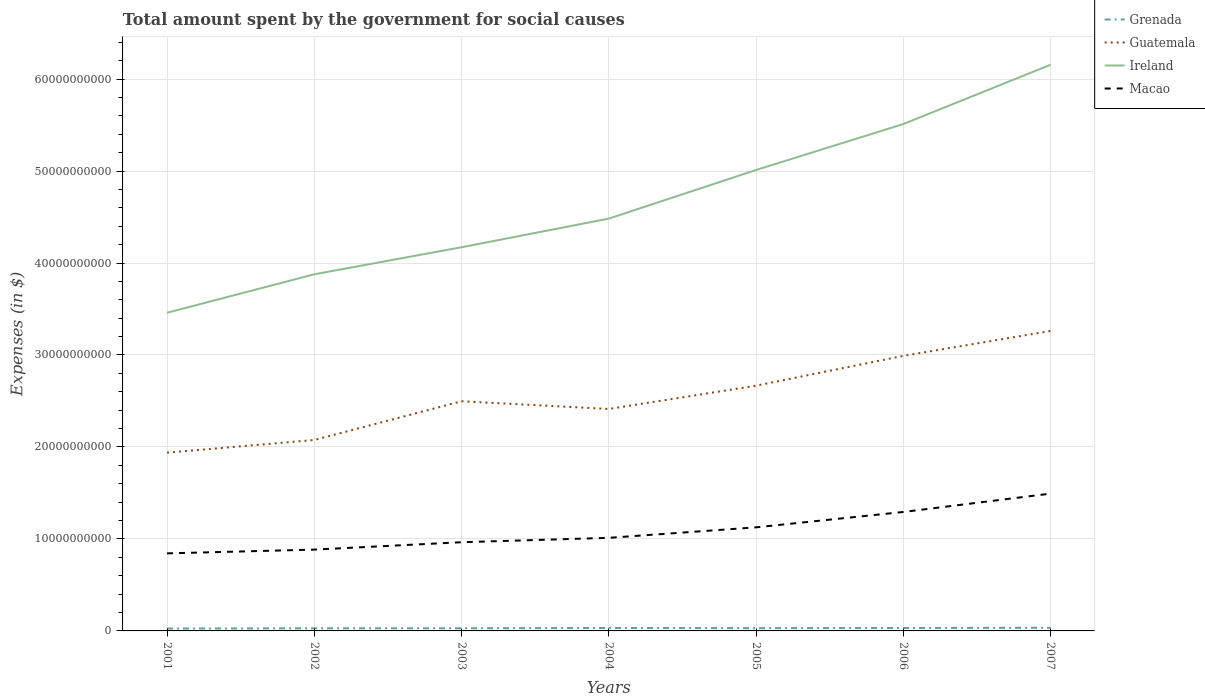How many different coloured lines are there?
Keep it short and to the point. 4. Does the line corresponding to Ireland intersect with the line corresponding to Grenada?
Your answer should be very brief. No. Across all years, what is the maximum amount spent for social causes by the government in Ireland?
Offer a terse response. 3.46e+1. What is the total amount spent for social causes by the government in Guatemala in the graph?
Offer a terse response. -9.15e+09. What is the difference between the highest and the second highest amount spent for social causes by the government in Grenada?
Keep it short and to the point. 8.76e+07. Does the graph contain any zero values?
Provide a short and direct response. No. Does the graph contain grids?
Keep it short and to the point. Yes. Where does the legend appear in the graph?
Provide a short and direct response. Top right. What is the title of the graph?
Your answer should be very brief. Total amount spent by the government for social causes. Does "East Asia (developing only)" appear as one of the legend labels in the graph?
Make the answer very short. No. What is the label or title of the X-axis?
Provide a succinct answer. Years. What is the label or title of the Y-axis?
Your response must be concise. Expenses (in $). What is the Expenses (in $) of Grenada in 2001?
Keep it short and to the point. 2.58e+08. What is the Expenses (in $) in Guatemala in 2001?
Provide a short and direct response. 1.94e+1. What is the Expenses (in $) in Ireland in 2001?
Provide a short and direct response. 3.46e+1. What is the Expenses (in $) of Macao in 2001?
Your answer should be compact. 8.43e+09. What is the Expenses (in $) in Grenada in 2002?
Ensure brevity in your answer.  2.83e+08. What is the Expenses (in $) in Guatemala in 2002?
Keep it short and to the point. 2.08e+1. What is the Expenses (in $) of Ireland in 2002?
Your response must be concise. 3.88e+1. What is the Expenses (in $) in Macao in 2002?
Offer a terse response. 8.84e+09. What is the Expenses (in $) in Grenada in 2003?
Your answer should be very brief. 2.86e+08. What is the Expenses (in $) of Guatemala in 2003?
Your response must be concise. 2.50e+1. What is the Expenses (in $) in Ireland in 2003?
Keep it short and to the point. 4.17e+1. What is the Expenses (in $) of Macao in 2003?
Your response must be concise. 9.64e+09. What is the Expenses (in $) in Grenada in 2004?
Provide a short and direct response. 3.21e+08. What is the Expenses (in $) in Guatemala in 2004?
Your answer should be very brief. 2.41e+1. What is the Expenses (in $) of Ireland in 2004?
Provide a short and direct response. 4.48e+1. What is the Expenses (in $) in Macao in 2004?
Offer a terse response. 1.01e+1. What is the Expenses (in $) in Grenada in 2005?
Offer a very short reply. 3.01e+08. What is the Expenses (in $) of Guatemala in 2005?
Your answer should be very brief. 2.67e+1. What is the Expenses (in $) in Ireland in 2005?
Provide a short and direct response. 5.01e+1. What is the Expenses (in $) of Macao in 2005?
Offer a terse response. 1.13e+1. What is the Expenses (in $) in Grenada in 2006?
Your answer should be very brief. 3.18e+08. What is the Expenses (in $) of Guatemala in 2006?
Offer a terse response. 2.99e+1. What is the Expenses (in $) in Ireland in 2006?
Ensure brevity in your answer.  5.51e+1. What is the Expenses (in $) in Macao in 2006?
Ensure brevity in your answer.  1.29e+1. What is the Expenses (in $) in Grenada in 2007?
Give a very brief answer. 3.46e+08. What is the Expenses (in $) in Guatemala in 2007?
Your answer should be compact. 3.26e+1. What is the Expenses (in $) in Ireland in 2007?
Offer a terse response. 6.16e+1. What is the Expenses (in $) of Macao in 2007?
Offer a terse response. 1.49e+1. Across all years, what is the maximum Expenses (in $) in Grenada?
Your answer should be very brief. 3.46e+08. Across all years, what is the maximum Expenses (in $) in Guatemala?
Provide a short and direct response. 3.26e+1. Across all years, what is the maximum Expenses (in $) of Ireland?
Your answer should be very brief. 6.16e+1. Across all years, what is the maximum Expenses (in $) of Macao?
Make the answer very short. 1.49e+1. Across all years, what is the minimum Expenses (in $) of Grenada?
Offer a very short reply. 2.58e+08. Across all years, what is the minimum Expenses (in $) of Guatemala?
Provide a short and direct response. 1.94e+1. Across all years, what is the minimum Expenses (in $) in Ireland?
Ensure brevity in your answer.  3.46e+1. Across all years, what is the minimum Expenses (in $) of Macao?
Your answer should be compact. 8.43e+09. What is the total Expenses (in $) in Grenada in the graph?
Ensure brevity in your answer.  2.11e+09. What is the total Expenses (in $) in Guatemala in the graph?
Your answer should be very brief. 1.78e+11. What is the total Expenses (in $) in Ireland in the graph?
Provide a short and direct response. 3.27e+11. What is the total Expenses (in $) of Macao in the graph?
Your answer should be very brief. 7.62e+1. What is the difference between the Expenses (in $) in Grenada in 2001 and that in 2002?
Keep it short and to the point. -2.49e+07. What is the difference between the Expenses (in $) in Guatemala in 2001 and that in 2002?
Offer a terse response. -1.38e+09. What is the difference between the Expenses (in $) of Ireland in 2001 and that in 2002?
Ensure brevity in your answer.  -4.18e+09. What is the difference between the Expenses (in $) in Macao in 2001 and that in 2002?
Provide a short and direct response. -4.10e+08. What is the difference between the Expenses (in $) of Grenada in 2001 and that in 2003?
Ensure brevity in your answer.  -2.73e+07. What is the difference between the Expenses (in $) in Guatemala in 2001 and that in 2003?
Provide a short and direct response. -5.59e+09. What is the difference between the Expenses (in $) in Ireland in 2001 and that in 2003?
Keep it short and to the point. -7.12e+09. What is the difference between the Expenses (in $) in Macao in 2001 and that in 2003?
Your answer should be compact. -1.21e+09. What is the difference between the Expenses (in $) in Grenada in 2001 and that in 2004?
Ensure brevity in your answer.  -6.24e+07. What is the difference between the Expenses (in $) in Guatemala in 2001 and that in 2004?
Your answer should be compact. -4.75e+09. What is the difference between the Expenses (in $) in Ireland in 2001 and that in 2004?
Give a very brief answer. -1.02e+1. What is the difference between the Expenses (in $) of Macao in 2001 and that in 2004?
Ensure brevity in your answer.  -1.69e+09. What is the difference between the Expenses (in $) of Grenada in 2001 and that in 2005?
Give a very brief answer. -4.27e+07. What is the difference between the Expenses (in $) of Guatemala in 2001 and that in 2005?
Your answer should be very brief. -7.28e+09. What is the difference between the Expenses (in $) in Ireland in 2001 and that in 2005?
Keep it short and to the point. -1.55e+1. What is the difference between the Expenses (in $) in Macao in 2001 and that in 2005?
Provide a short and direct response. -2.83e+09. What is the difference between the Expenses (in $) in Grenada in 2001 and that in 2006?
Your answer should be compact. -5.91e+07. What is the difference between the Expenses (in $) of Guatemala in 2001 and that in 2006?
Ensure brevity in your answer.  -1.05e+1. What is the difference between the Expenses (in $) in Ireland in 2001 and that in 2006?
Your answer should be compact. -2.05e+1. What is the difference between the Expenses (in $) of Macao in 2001 and that in 2006?
Provide a succinct answer. -4.50e+09. What is the difference between the Expenses (in $) of Grenada in 2001 and that in 2007?
Give a very brief answer. -8.76e+07. What is the difference between the Expenses (in $) of Guatemala in 2001 and that in 2007?
Keep it short and to the point. -1.32e+1. What is the difference between the Expenses (in $) in Ireland in 2001 and that in 2007?
Provide a succinct answer. -2.70e+1. What is the difference between the Expenses (in $) of Macao in 2001 and that in 2007?
Offer a terse response. -6.50e+09. What is the difference between the Expenses (in $) of Grenada in 2002 and that in 2003?
Give a very brief answer. -2.40e+06. What is the difference between the Expenses (in $) of Guatemala in 2002 and that in 2003?
Give a very brief answer. -4.21e+09. What is the difference between the Expenses (in $) in Ireland in 2002 and that in 2003?
Keep it short and to the point. -2.94e+09. What is the difference between the Expenses (in $) of Macao in 2002 and that in 2003?
Make the answer very short. -8.02e+08. What is the difference between the Expenses (in $) in Grenada in 2002 and that in 2004?
Your response must be concise. -3.75e+07. What is the difference between the Expenses (in $) in Guatemala in 2002 and that in 2004?
Your answer should be compact. -3.37e+09. What is the difference between the Expenses (in $) in Ireland in 2002 and that in 2004?
Your response must be concise. -6.05e+09. What is the difference between the Expenses (in $) in Macao in 2002 and that in 2004?
Keep it short and to the point. -1.28e+09. What is the difference between the Expenses (in $) of Grenada in 2002 and that in 2005?
Provide a succinct answer. -1.78e+07. What is the difference between the Expenses (in $) of Guatemala in 2002 and that in 2005?
Your answer should be compact. -5.90e+09. What is the difference between the Expenses (in $) in Ireland in 2002 and that in 2005?
Offer a very short reply. -1.13e+1. What is the difference between the Expenses (in $) in Macao in 2002 and that in 2005?
Your answer should be compact. -2.42e+09. What is the difference between the Expenses (in $) of Grenada in 2002 and that in 2006?
Make the answer very short. -3.42e+07. What is the difference between the Expenses (in $) in Guatemala in 2002 and that in 2006?
Keep it short and to the point. -9.15e+09. What is the difference between the Expenses (in $) of Ireland in 2002 and that in 2006?
Keep it short and to the point. -1.63e+1. What is the difference between the Expenses (in $) of Macao in 2002 and that in 2006?
Your answer should be compact. -4.09e+09. What is the difference between the Expenses (in $) in Grenada in 2002 and that in 2007?
Your response must be concise. -6.27e+07. What is the difference between the Expenses (in $) in Guatemala in 2002 and that in 2007?
Your response must be concise. -1.18e+1. What is the difference between the Expenses (in $) of Ireland in 2002 and that in 2007?
Offer a very short reply. -2.28e+1. What is the difference between the Expenses (in $) in Macao in 2002 and that in 2007?
Offer a terse response. -6.09e+09. What is the difference between the Expenses (in $) in Grenada in 2003 and that in 2004?
Provide a succinct answer. -3.51e+07. What is the difference between the Expenses (in $) in Guatemala in 2003 and that in 2004?
Your answer should be very brief. 8.40e+08. What is the difference between the Expenses (in $) of Ireland in 2003 and that in 2004?
Provide a succinct answer. -3.11e+09. What is the difference between the Expenses (in $) of Macao in 2003 and that in 2004?
Provide a succinct answer. -4.76e+08. What is the difference between the Expenses (in $) in Grenada in 2003 and that in 2005?
Your response must be concise. -1.54e+07. What is the difference between the Expenses (in $) of Guatemala in 2003 and that in 2005?
Your answer should be very brief. -1.69e+09. What is the difference between the Expenses (in $) in Ireland in 2003 and that in 2005?
Keep it short and to the point. -8.40e+09. What is the difference between the Expenses (in $) in Macao in 2003 and that in 2005?
Your answer should be very brief. -1.62e+09. What is the difference between the Expenses (in $) of Grenada in 2003 and that in 2006?
Give a very brief answer. -3.18e+07. What is the difference between the Expenses (in $) in Guatemala in 2003 and that in 2006?
Your answer should be compact. -4.94e+09. What is the difference between the Expenses (in $) of Ireland in 2003 and that in 2006?
Give a very brief answer. -1.34e+1. What is the difference between the Expenses (in $) of Macao in 2003 and that in 2006?
Make the answer very short. -3.29e+09. What is the difference between the Expenses (in $) of Grenada in 2003 and that in 2007?
Provide a succinct answer. -6.03e+07. What is the difference between the Expenses (in $) in Guatemala in 2003 and that in 2007?
Provide a short and direct response. -7.64e+09. What is the difference between the Expenses (in $) of Ireland in 2003 and that in 2007?
Ensure brevity in your answer.  -1.98e+1. What is the difference between the Expenses (in $) in Macao in 2003 and that in 2007?
Offer a very short reply. -5.28e+09. What is the difference between the Expenses (in $) of Grenada in 2004 and that in 2005?
Your answer should be compact. 1.97e+07. What is the difference between the Expenses (in $) of Guatemala in 2004 and that in 2005?
Your response must be concise. -2.53e+09. What is the difference between the Expenses (in $) of Ireland in 2004 and that in 2005?
Offer a terse response. -5.29e+09. What is the difference between the Expenses (in $) of Macao in 2004 and that in 2005?
Make the answer very short. -1.14e+09. What is the difference between the Expenses (in $) of Grenada in 2004 and that in 2006?
Give a very brief answer. 3.30e+06. What is the difference between the Expenses (in $) in Guatemala in 2004 and that in 2006?
Give a very brief answer. -5.78e+09. What is the difference between the Expenses (in $) of Ireland in 2004 and that in 2006?
Make the answer very short. -1.03e+1. What is the difference between the Expenses (in $) in Macao in 2004 and that in 2006?
Give a very brief answer. -2.81e+09. What is the difference between the Expenses (in $) in Grenada in 2004 and that in 2007?
Your answer should be very brief. -2.52e+07. What is the difference between the Expenses (in $) in Guatemala in 2004 and that in 2007?
Your answer should be very brief. -8.48e+09. What is the difference between the Expenses (in $) of Ireland in 2004 and that in 2007?
Ensure brevity in your answer.  -1.67e+1. What is the difference between the Expenses (in $) in Macao in 2004 and that in 2007?
Ensure brevity in your answer.  -4.81e+09. What is the difference between the Expenses (in $) in Grenada in 2005 and that in 2006?
Make the answer very short. -1.64e+07. What is the difference between the Expenses (in $) of Guatemala in 2005 and that in 2006?
Your answer should be very brief. -3.24e+09. What is the difference between the Expenses (in $) of Ireland in 2005 and that in 2006?
Your answer should be very brief. -4.99e+09. What is the difference between the Expenses (in $) of Macao in 2005 and that in 2006?
Make the answer very short. -1.67e+09. What is the difference between the Expenses (in $) in Grenada in 2005 and that in 2007?
Your response must be concise. -4.49e+07. What is the difference between the Expenses (in $) of Guatemala in 2005 and that in 2007?
Offer a very short reply. -5.95e+09. What is the difference between the Expenses (in $) of Ireland in 2005 and that in 2007?
Offer a very short reply. -1.14e+1. What is the difference between the Expenses (in $) in Macao in 2005 and that in 2007?
Your answer should be very brief. -3.67e+09. What is the difference between the Expenses (in $) in Grenada in 2006 and that in 2007?
Ensure brevity in your answer.  -2.85e+07. What is the difference between the Expenses (in $) of Guatemala in 2006 and that in 2007?
Make the answer very short. -2.70e+09. What is the difference between the Expenses (in $) in Ireland in 2006 and that in 2007?
Your answer should be very brief. -6.45e+09. What is the difference between the Expenses (in $) in Macao in 2006 and that in 2007?
Give a very brief answer. -2.00e+09. What is the difference between the Expenses (in $) in Grenada in 2001 and the Expenses (in $) in Guatemala in 2002?
Your answer should be compact. -2.05e+1. What is the difference between the Expenses (in $) in Grenada in 2001 and the Expenses (in $) in Ireland in 2002?
Keep it short and to the point. -3.85e+1. What is the difference between the Expenses (in $) in Grenada in 2001 and the Expenses (in $) in Macao in 2002?
Offer a very short reply. -8.58e+09. What is the difference between the Expenses (in $) of Guatemala in 2001 and the Expenses (in $) of Ireland in 2002?
Give a very brief answer. -1.94e+1. What is the difference between the Expenses (in $) in Guatemala in 2001 and the Expenses (in $) in Macao in 2002?
Give a very brief answer. 1.05e+1. What is the difference between the Expenses (in $) of Ireland in 2001 and the Expenses (in $) of Macao in 2002?
Your answer should be compact. 2.57e+1. What is the difference between the Expenses (in $) in Grenada in 2001 and the Expenses (in $) in Guatemala in 2003?
Provide a short and direct response. -2.47e+1. What is the difference between the Expenses (in $) in Grenada in 2001 and the Expenses (in $) in Ireland in 2003?
Provide a short and direct response. -4.15e+1. What is the difference between the Expenses (in $) of Grenada in 2001 and the Expenses (in $) of Macao in 2003?
Make the answer very short. -9.39e+09. What is the difference between the Expenses (in $) in Guatemala in 2001 and the Expenses (in $) in Ireland in 2003?
Make the answer very short. -2.23e+1. What is the difference between the Expenses (in $) in Guatemala in 2001 and the Expenses (in $) in Macao in 2003?
Offer a terse response. 9.74e+09. What is the difference between the Expenses (in $) of Ireland in 2001 and the Expenses (in $) of Macao in 2003?
Ensure brevity in your answer.  2.49e+1. What is the difference between the Expenses (in $) in Grenada in 2001 and the Expenses (in $) in Guatemala in 2004?
Provide a short and direct response. -2.39e+1. What is the difference between the Expenses (in $) in Grenada in 2001 and the Expenses (in $) in Ireland in 2004?
Provide a short and direct response. -4.46e+1. What is the difference between the Expenses (in $) of Grenada in 2001 and the Expenses (in $) of Macao in 2004?
Provide a succinct answer. -9.86e+09. What is the difference between the Expenses (in $) in Guatemala in 2001 and the Expenses (in $) in Ireland in 2004?
Offer a very short reply. -2.54e+1. What is the difference between the Expenses (in $) of Guatemala in 2001 and the Expenses (in $) of Macao in 2004?
Keep it short and to the point. 9.26e+09. What is the difference between the Expenses (in $) in Ireland in 2001 and the Expenses (in $) in Macao in 2004?
Ensure brevity in your answer.  2.45e+1. What is the difference between the Expenses (in $) of Grenada in 2001 and the Expenses (in $) of Guatemala in 2005?
Give a very brief answer. -2.64e+1. What is the difference between the Expenses (in $) in Grenada in 2001 and the Expenses (in $) in Ireland in 2005?
Keep it short and to the point. -4.99e+1. What is the difference between the Expenses (in $) in Grenada in 2001 and the Expenses (in $) in Macao in 2005?
Ensure brevity in your answer.  -1.10e+1. What is the difference between the Expenses (in $) of Guatemala in 2001 and the Expenses (in $) of Ireland in 2005?
Your answer should be compact. -3.07e+1. What is the difference between the Expenses (in $) of Guatemala in 2001 and the Expenses (in $) of Macao in 2005?
Offer a very short reply. 8.12e+09. What is the difference between the Expenses (in $) in Ireland in 2001 and the Expenses (in $) in Macao in 2005?
Provide a short and direct response. 2.33e+1. What is the difference between the Expenses (in $) of Grenada in 2001 and the Expenses (in $) of Guatemala in 2006?
Provide a short and direct response. -2.96e+1. What is the difference between the Expenses (in $) in Grenada in 2001 and the Expenses (in $) in Ireland in 2006?
Offer a terse response. -5.48e+1. What is the difference between the Expenses (in $) in Grenada in 2001 and the Expenses (in $) in Macao in 2006?
Provide a short and direct response. -1.27e+1. What is the difference between the Expenses (in $) in Guatemala in 2001 and the Expenses (in $) in Ireland in 2006?
Your answer should be very brief. -3.57e+1. What is the difference between the Expenses (in $) in Guatemala in 2001 and the Expenses (in $) in Macao in 2006?
Provide a succinct answer. 6.45e+09. What is the difference between the Expenses (in $) in Ireland in 2001 and the Expenses (in $) in Macao in 2006?
Offer a terse response. 2.17e+1. What is the difference between the Expenses (in $) of Grenada in 2001 and the Expenses (in $) of Guatemala in 2007?
Your answer should be very brief. -3.23e+1. What is the difference between the Expenses (in $) of Grenada in 2001 and the Expenses (in $) of Ireland in 2007?
Your response must be concise. -6.13e+1. What is the difference between the Expenses (in $) in Grenada in 2001 and the Expenses (in $) in Macao in 2007?
Your response must be concise. -1.47e+1. What is the difference between the Expenses (in $) in Guatemala in 2001 and the Expenses (in $) in Ireland in 2007?
Offer a terse response. -4.22e+1. What is the difference between the Expenses (in $) in Guatemala in 2001 and the Expenses (in $) in Macao in 2007?
Ensure brevity in your answer.  4.45e+09. What is the difference between the Expenses (in $) in Ireland in 2001 and the Expenses (in $) in Macao in 2007?
Ensure brevity in your answer.  1.97e+1. What is the difference between the Expenses (in $) of Grenada in 2002 and the Expenses (in $) of Guatemala in 2003?
Your answer should be compact. -2.47e+1. What is the difference between the Expenses (in $) in Grenada in 2002 and the Expenses (in $) in Ireland in 2003?
Your answer should be very brief. -4.14e+1. What is the difference between the Expenses (in $) of Grenada in 2002 and the Expenses (in $) of Macao in 2003?
Keep it short and to the point. -9.36e+09. What is the difference between the Expenses (in $) of Guatemala in 2002 and the Expenses (in $) of Ireland in 2003?
Provide a succinct answer. -2.10e+1. What is the difference between the Expenses (in $) of Guatemala in 2002 and the Expenses (in $) of Macao in 2003?
Keep it short and to the point. 1.11e+1. What is the difference between the Expenses (in $) in Ireland in 2002 and the Expenses (in $) in Macao in 2003?
Provide a short and direct response. 2.91e+1. What is the difference between the Expenses (in $) of Grenada in 2002 and the Expenses (in $) of Guatemala in 2004?
Your answer should be very brief. -2.38e+1. What is the difference between the Expenses (in $) in Grenada in 2002 and the Expenses (in $) in Ireland in 2004?
Provide a short and direct response. -4.45e+1. What is the difference between the Expenses (in $) of Grenada in 2002 and the Expenses (in $) of Macao in 2004?
Offer a very short reply. -9.84e+09. What is the difference between the Expenses (in $) of Guatemala in 2002 and the Expenses (in $) of Ireland in 2004?
Ensure brevity in your answer.  -2.41e+1. What is the difference between the Expenses (in $) in Guatemala in 2002 and the Expenses (in $) in Macao in 2004?
Your answer should be very brief. 1.06e+1. What is the difference between the Expenses (in $) in Ireland in 2002 and the Expenses (in $) in Macao in 2004?
Provide a succinct answer. 2.87e+1. What is the difference between the Expenses (in $) of Grenada in 2002 and the Expenses (in $) of Guatemala in 2005?
Your answer should be very brief. -2.64e+1. What is the difference between the Expenses (in $) of Grenada in 2002 and the Expenses (in $) of Ireland in 2005?
Keep it short and to the point. -4.98e+1. What is the difference between the Expenses (in $) of Grenada in 2002 and the Expenses (in $) of Macao in 2005?
Give a very brief answer. -1.10e+1. What is the difference between the Expenses (in $) of Guatemala in 2002 and the Expenses (in $) of Ireland in 2005?
Offer a terse response. -2.94e+1. What is the difference between the Expenses (in $) of Guatemala in 2002 and the Expenses (in $) of Macao in 2005?
Offer a very short reply. 9.50e+09. What is the difference between the Expenses (in $) in Ireland in 2002 and the Expenses (in $) in Macao in 2005?
Make the answer very short. 2.75e+1. What is the difference between the Expenses (in $) in Grenada in 2002 and the Expenses (in $) in Guatemala in 2006?
Provide a short and direct response. -2.96e+1. What is the difference between the Expenses (in $) in Grenada in 2002 and the Expenses (in $) in Ireland in 2006?
Your answer should be very brief. -5.48e+1. What is the difference between the Expenses (in $) in Grenada in 2002 and the Expenses (in $) in Macao in 2006?
Offer a terse response. -1.26e+1. What is the difference between the Expenses (in $) in Guatemala in 2002 and the Expenses (in $) in Ireland in 2006?
Ensure brevity in your answer.  -3.43e+1. What is the difference between the Expenses (in $) in Guatemala in 2002 and the Expenses (in $) in Macao in 2006?
Your answer should be compact. 7.83e+09. What is the difference between the Expenses (in $) of Ireland in 2002 and the Expenses (in $) of Macao in 2006?
Make the answer very short. 2.58e+1. What is the difference between the Expenses (in $) of Grenada in 2002 and the Expenses (in $) of Guatemala in 2007?
Offer a very short reply. -3.23e+1. What is the difference between the Expenses (in $) of Grenada in 2002 and the Expenses (in $) of Ireland in 2007?
Offer a very short reply. -6.13e+1. What is the difference between the Expenses (in $) of Grenada in 2002 and the Expenses (in $) of Macao in 2007?
Provide a short and direct response. -1.46e+1. What is the difference between the Expenses (in $) of Guatemala in 2002 and the Expenses (in $) of Ireland in 2007?
Your answer should be compact. -4.08e+1. What is the difference between the Expenses (in $) in Guatemala in 2002 and the Expenses (in $) in Macao in 2007?
Your answer should be compact. 5.83e+09. What is the difference between the Expenses (in $) of Ireland in 2002 and the Expenses (in $) of Macao in 2007?
Provide a succinct answer. 2.38e+1. What is the difference between the Expenses (in $) in Grenada in 2003 and the Expenses (in $) in Guatemala in 2004?
Make the answer very short. -2.38e+1. What is the difference between the Expenses (in $) of Grenada in 2003 and the Expenses (in $) of Ireland in 2004?
Offer a terse response. -4.45e+1. What is the difference between the Expenses (in $) in Grenada in 2003 and the Expenses (in $) in Macao in 2004?
Ensure brevity in your answer.  -9.83e+09. What is the difference between the Expenses (in $) of Guatemala in 2003 and the Expenses (in $) of Ireland in 2004?
Offer a very short reply. -1.99e+1. What is the difference between the Expenses (in $) of Guatemala in 2003 and the Expenses (in $) of Macao in 2004?
Make the answer very short. 1.48e+1. What is the difference between the Expenses (in $) in Ireland in 2003 and the Expenses (in $) in Macao in 2004?
Offer a terse response. 3.16e+1. What is the difference between the Expenses (in $) of Grenada in 2003 and the Expenses (in $) of Guatemala in 2005?
Give a very brief answer. -2.64e+1. What is the difference between the Expenses (in $) of Grenada in 2003 and the Expenses (in $) of Ireland in 2005?
Keep it short and to the point. -4.98e+1. What is the difference between the Expenses (in $) of Grenada in 2003 and the Expenses (in $) of Macao in 2005?
Offer a terse response. -1.10e+1. What is the difference between the Expenses (in $) in Guatemala in 2003 and the Expenses (in $) in Ireland in 2005?
Your answer should be compact. -2.51e+1. What is the difference between the Expenses (in $) of Guatemala in 2003 and the Expenses (in $) of Macao in 2005?
Keep it short and to the point. 1.37e+1. What is the difference between the Expenses (in $) in Ireland in 2003 and the Expenses (in $) in Macao in 2005?
Offer a terse response. 3.05e+1. What is the difference between the Expenses (in $) of Grenada in 2003 and the Expenses (in $) of Guatemala in 2006?
Keep it short and to the point. -2.96e+1. What is the difference between the Expenses (in $) in Grenada in 2003 and the Expenses (in $) in Ireland in 2006?
Give a very brief answer. -5.48e+1. What is the difference between the Expenses (in $) of Grenada in 2003 and the Expenses (in $) of Macao in 2006?
Provide a succinct answer. -1.26e+1. What is the difference between the Expenses (in $) of Guatemala in 2003 and the Expenses (in $) of Ireland in 2006?
Make the answer very short. -3.01e+1. What is the difference between the Expenses (in $) in Guatemala in 2003 and the Expenses (in $) in Macao in 2006?
Give a very brief answer. 1.20e+1. What is the difference between the Expenses (in $) of Ireland in 2003 and the Expenses (in $) of Macao in 2006?
Offer a very short reply. 2.88e+1. What is the difference between the Expenses (in $) in Grenada in 2003 and the Expenses (in $) in Guatemala in 2007?
Make the answer very short. -3.23e+1. What is the difference between the Expenses (in $) in Grenada in 2003 and the Expenses (in $) in Ireland in 2007?
Your answer should be compact. -6.13e+1. What is the difference between the Expenses (in $) in Grenada in 2003 and the Expenses (in $) in Macao in 2007?
Make the answer very short. -1.46e+1. What is the difference between the Expenses (in $) of Guatemala in 2003 and the Expenses (in $) of Ireland in 2007?
Make the answer very short. -3.66e+1. What is the difference between the Expenses (in $) in Guatemala in 2003 and the Expenses (in $) in Macao in 2007?
Your answer should be very brief. 1.00e+1. What is the difference between the Expenses (in $) of Ireland in 2003 and the Expenses (in $) of Macao in 2007?
Give a very brief answer. 2.68e+1. What is the difference between the Expenses (in $) of Grenada in 2004 and the Expenses (in $) of Guatemala in 2005?
Your response must be concise. -2.63e+1. What is the difference between the Expenses (in $) in Grenada in 2004 and the Expenses (in $) in Ireland in 2005?
Your response must be concise. -4.98e+1. What is the difference between the Expenses (in $) of Grenada in 2004 and the Expenses (in $) of Macao in 2005?
Provide a short and direct response. -1.09e+1. What is the difference between the Expenses (in $) in Guatemala in 2004 and the Expenses (in $) in Ireland in 2005?
Your answer should be very brief. -2.60e+1. What is the difference between the Expenses (in $) of Guatemala in 2004 and the Expenses (in $) of Macao in 2005?
Make the answer very short. 1.29e+1. What is the difference between the Expenses (in $) in Ireland in 2004 and the Expenses (in $) in Macao in 2005?
Offer a very short reply. 3.36e+1. What is the difference between the Expenses (in $) of Grenada in 2004 and the Expenses (in $) of Guatemala in 2006?
Your answer should be very brief. -2.96e+1. What is the difference between the Expenses (in $) in Grenada in 2004 and the Expenses (in $) in Ireland in 2006?
Your answer should be compact. -5.48e+1. What is the difference between the Expenses (in $) of Grenada in 2004 and the Expenses (in $) of Macao in 2006?
Make the answer very short. -1.26e+1. What is the difference between the Expenses (in $) in Guatemala in 2004 and the Expenses (in $) in Ireland in 2006?
Your answer should be compact. -3.10e+1. What is the difference between the Expenses (in $) of Guatemala in 2004 and the Expenses (in $) of Macao in 2006?
Keep it short and to the point. 1.12e+1. What is the difference between the Expenses (in $) of Ireland in 2004 and the Expenses (in $) of Macao in 2006?
Your answer should be compact. 3.19e+1. What is the difference between the Expenses (in $) of Grenada in 2004 and the Expenses (in $) of Guatemala in 2007?
Offer a very short reply. -3.23e+1. What is the difference between the Expenses (in $) of Grenada in 2004 and the Expenses (in $) of Ireland in 2007?
Your answer should be very brief. -6.12e+1. What is the difference between the Expenses (in $) of Grenada in 2004 and the Expenses (in $) of Macao in 2007?
Give a very brief answer. -1.46e+1. What is the difference between the Expenses (in $) in Guatemala in 2004 and the Expenses (in $) in Ireland in 2007?
Keep it short and to the point. -3.74e+1. What is the difference between the Expenses (in $) of Guatemala in 2004 and the Expenses (in $) of Macao in 2007?
Provide a succinct answer. 9.20e+09. What is the difference between the Expenses (in $) in Ireland in 2004 and the Expenses (in $) in Macao in 2007?
Make the answer very short. 2.99e+1. What is the difference between the Expenses (in $) in Grenada in 2005 and the Expenses (in $) in Guatemala in 2006?
Make the answer very short. -2.96e+1. What is the difference between the Expenses (in $) of Grenada in 2005 and the Expenses (in $) of Ireland in 2006?
Offer a very short reply. -5.48e+1. What is the difference between the Expenses (in $) of Grenada in 2005 and the Expenses (in $) of Macao in 2006?
Your answer should be compact. -1.26e+1. What is the difference between the Expenses (in $) in Guatemala in 2005 and the Expenses (in $) in Ireland in 2006?
Ensure brevity in your answer.  -2.84e+1. What is the difference between the Expenses (in $) of Guatemala in 2005 and the Expenses (in $) of Macao in 2006?
Keep it short and to the point. 1.37e+1. What is the difference between the Expenses (in $) of Ireland in 2005 and the Expenses (in $) of Macao in 2006?
Offer a terse response. 3.72e+1. What is the difference between the Expenses (in $) of Grenada in 2005 and the Expenses (in $) of Guatemala in 2007?
Ensure brevity in your answer.  -3.23e+1. What is the difference between the Expenses (in $) of Grenada in 2005 and the Expenses (in $) of Ireland in 2007?
Your answer should be very brief. -6.13e+1. What is the difference between the Expenses (in $) in Grenada in 2005 and the Expenses (in $) in Macao in 2007?
Your answer should be compact. -1.46e+1. What is the difference between the Expenses (in $) in Guatemala in 2005 and the Expenses (in $) in Ireland in 2007?
Your answer should be very brief. -3.49e+1. What is the difference between the Expenses (in $) of Guatemala in 2005 and the Expenses (in $) of Macao in 2007?
Your answer should be compact. 1.17e+1. What is the difference between the Expenses (in $) in Ireland in 2005 and the Expenses (in $) in Macao in 2007?
Provide a succinct answer. 3.52e+1. What is the difference between the Expenses (in $) in Grenada in 2006 and the Expenses (in $) in Guatemala in 2007?
Ensure brevity in your answer.  -3.23e+1. What is the difference between the Expenses (in $) in Grenada in 2006 and the Expenses (in $) in Ireland in 2007?
Your answer should be compact. -6.12e+1. What is the difference between the Expenses (in $) in Grenada in 2006 and the Expenses (in $) in Macao in 2007?
Your answer should be compact. -1.46e+1. What is the difference between the Expenses (in $) in Guatemala in 2006 and the Expenses (in $) in Ireland in 2007?
Make the answer very short. -3.16e+1. What is the difference between the Expenses (in $) of Guatemala in 2006 and the Expenses (in $) of Macao in 2007?
Provide a succinct answer. 1.50e+1. What is the difference between the Expenses (in $) of Ireland in 2006 and the Expenses (in $) of Macao in 2007?
Make the answer very short. 4.02e+1. What is the average Expenses (in $) in Grenada per year?
Keep it short and to the point. 3.02e+08. What is the average Expenses (in $) in Guatemala per year?
Make the answer very short. 2.55e+1. What is the average Expenses (in $) in Ireland per year?
Make the answer very short. 4.67e+1. What is the average Expenses (in $) in Macao per year?
Make the answer very short. 1.09e+1. In the year 2001, what is the difference between the Expenses (in $) in Grenada and Expenses (in $) in Guatemala?
Keep it short and to the point. -1.91e+1. In the year 2001, what is the difference between the Expenses (in $) in Grenada and Expenses (in $) in Ireland?
Your response must be concise. -3.43e+1. In the year 2001, what is the difference between the Expenses (in $) in Grenada and Expenses (in $) in Macao?
Your answer should be compact. -8.17e+09. In the year 2001, what is the difference between the Expenses (in $) of Guatemala and Expenses (in $) of Ireland?
Offer a very short reply. -1.52e+1. In the year 2001, what is the difference between the Expenses (in $) in Guatemala and Expenses (in $) in Macao?
Provide a succinct answer. 1.09e+1. In the year 2001, what is the difference between the Expenses (in $) in Ireland and Expenses (in $) in Macao?
Offer a terse response. 2.62e+1. In the year 2002, what is the difference between the Expenses (in $) of Grenada and Expenses (in $) of Guatemala?
Your answer should be compact. -2.05e+1. In the year 2002, what is the difference between the Expenses (in $) in Grenada and Expenses (in $) in Ireland?
Provide a short and direct response. -3.85e+1. In the year 2002, what is the difference between the Expenses (in $) of Grenada and Expenses (in $) of Macao?
Your answer should be compact. -8.56e+09. In the year 2002, what is the difference between the Expenses (in $) of Guatemala and Expenses (in $) of Ireland?
Your answer should be compact. -1.80e+1. In the year 2002, what is the difference between the Expenses (in $) of Guatemala and Expenses (in $) of Macao?
Ensure brevity in your answer.  1.19e+1. In the year 2002, what is the difference between the Expenses (in $) in Ireland and Expenses (in $) in Macao?
Keep it short and to the point. 2.99e+1. In the year 2003, what is the difference between the Expenses (in $) in Grenada and Expenses (in $) in Guatemala?
Offer a terse response. -2.47e+1. In the year 2003, what is the difference between the Expenses (in $) in Grenada and Expenses (in $) in Ireland?
Your answer should be compact. -4.14e+1. In the year 2003, what is the difference between the Expenses (in $) of Grenada and Expenses (in $) of Macao?
Provide a succinct answer. -9.36e+09. In the year 2003, what is the difference between the Expenses (in $) in Guatemala and Expenses (in $) in Ireland?
Ensure brevity in your answer.  -1.67e+1. In the year 2003, what is the difference between the Expenses (in $) of Guatemala and Expenses (in $) of Macao?
Ensure brevity in your answer.  1.53e+1. In the year 2003, what is the difference between the Expenses (in $) in Ireland and Expenses (in $) in Macao?
Give a very brief answer. 3.21e+1. In the year 2004, what is the difference between the Expenses (in $) in Grenada and Expenses (in $) in Guatemala?
Your answer should be compact. -2.38e+1. In the year 2004, what is the difference between the Expenses (in $) in Grenada and Expenses (in $) in Ireland?
Your answer should be compact. -4.45e+1. In the year 2004, what is the difference between the Expenses (in $) in Grenada and Expenses (in $) in Macao?
Your answer should be very brief. -9.80e+09. In the year 2004, what is the difference between the Expenses (in $) of Guatemala and Expenses (in $) of Ireland?
Your answer should be very brief. -2.07e+1. In the year 2004, what is the difference between the Expenses (in $) of Guatemala and Expenses (in $) of Macao?
Provide a succinct answer. 1.40e+1. In the year 2004, what is the difference between the Expenses (in $) of Ireland and Expenses (in $) of Macao?
Your response must be concise. 3.47e+1. In the year 2005, what is the difference between the Expenses (in $) in Grenada and Expenses (in $) in Guatemala?
Provide a succinct answer. -2.64e+1. In the year 2005, what is the difference between the Expenses (in $) of Grenada and Expenses (in $) of Ireland?
Ensure brevity in your answer.  -4.98e+1. In the year 2005, what is the difference between the Expenses (in $) in Grenada and Expenses (in $) in Macao?
Provide a succinct answer. -1.10e+1. In the year 2005, what is the difference between the Expenses (in $) of Guatemala and Expenses (in $) of Ireland?
Offer a terse response. -2.35e+1. In the year 2005, what is the difference between the Expenses (in $) in Guatemala and Expenses (in $) in Macao?
Your answer should be compact. 1.54e+1. In the year 2005, what is the difference between the Expenses (in $) in Ireland and Expenses (in $) in Macao?
Give a very brief answer. 3.89e+1. In the year 2006, what is the difference between the Expenses (in $) in Grenada and Expenses (in $) in Guatemala?
Give a very brief answer. -2.96e+1. In the year 2006, what is the difference between the Expenses (in $) of Grenada and Expenses (in $) of Ireland?
Keep it short and to the point. -5.48e+1. In the year 2006, what is the difference between the Expenses (in $) of Grenada and Expenses (in $) of Macao?
Offer a very short reply. -1.26e+1. In the year 2006, what is the difference between the Expenses (in $) of Guatemala and Expenses (in $) of Ireland?
Provide a succinct answer. -2.52e+1. In the year 2006, what is the difference between the Expenses (in $) of Guatemala and Expenses (in $) of Macao?
Provide a short and direct response. 1.70e+1. In the year 2006, what is the difference between the Expenses (in $) in Ireland and Expenses (in $) in Macao?
Offer a terse response. 4.22e+1. In the year 2007, what is the difference between the Expenses (in $) of Grenada and Expenses (in $) of Guatemala?
Make the answer very short. -3.23e+1. In the year 2007, what is the difference between the Expenses (in $) of Grenada and Expenses (in $) of Ireland?
Make the answer very short. -6.12e+1. In the year 2007, what is the difference between the Expenses (in $) of Grenada and Expenses (in $) of Macao?
Offer a very short reply. -1.46e+1. In the year 2007, what is the difference between the Expenses (in $) in Guatemala and Expenses (in $) in Ireland?
Your answer should be very brief. -2.89e+1. In the year 2007, what is the difference between the Expenses (in $) of Guatemala and Expenses (in $) of Macao?
Your answer should be compact. 1.77e+1. In the year 2007, what is the difference between the Expenses (in $) of Ireland and Expenses (in $) of Macao?
Give a very brief answer. 4.66e+1. What is the ratio of the Expenses (in $) in Grenada in 2001 to that in 2002?
Keep it short and to the point. 0.91. What is the ratio of the Expenses (in $) of Guatemala in 2001 to that in 2002?
Ensure brevity in your answer.  0.93. What is the ratio of the Expenses (in $) of Ireland in 2001 to that in 2002?
Give a very brief answer. 0.89. What is the ratio of the Expenses (in $) in Macao in 2001 to that in 2002?
Offer a very short reply. 0.95. What is the ratio of the Expenses (in $) of Grenada in 2001 to that in 2003?
Your answer should be compact. 0.9. What is the ratio of the Expenses (in $) in Guatemala in 2001 to that in 2003?
Ensure brevity in your answer.  0.78. What is the ratio of the Expenses (in $) in Ireland in 2001 to that in 2003?
Make the answer very short. 0.83. What is the ratio of the Expenses (in $) in Macao in 2001 to that in 2003?
Offer a very short reply. 0.87. What is the ratio of the Expenses (in $) of Grenada in 2001 to that in 2004?
Give a very brief answer. 0.81. What is the ratio of the Expenses (in $) of Guatemala in 2001 to that in 2004?
Your answer should be compact. 0.8. What is the ratio of the Expenses (in $) in Ireland in 2001 to that in 2004?
Give a very brief answer. 0.77. What is the ratio of the Expenses (in $) of Macao in 2001 to that in 2004?
Provide a short and direct response. 0.83. What is the ratio of the Expenses (in $) of Grenada in 2001 to that in 2005?
Your response must be concise. 0.86. What is the ratio of the Expenses (in $) of Guatemala in 2001 to that in 2005?
Your answer should be compact. 0.73. What is the ratio of the Expenses (in $) in Ireland in 2001 to that in 2005?
Ensure brevity in your answer.  0.69. What is the ratio of the Expenses (in $) of Macao in 2001 to that in 2005?
Offer a terse response. 0.75. What is the ratio of the Expenses (in $) of Grenada in 2001 to that in 2006?
Your response must be concise. 0.81. What is the ratio of the Expenses (in $) of Guatemala in 2001 to that in 2006?
Your answer should be compact. 0.65. What is the ratio of the Expenses (in $) in Ireland in 2001 to that in 2006?
Keep it short and to the point. 0.63. What is the ratio of the Expenses (in $) in Macao in 2001 to that in 2006?
Provide a succinct answer. 0.65. What is the ratio of the Expenses (in $) of Grenada in 2001 to that in 2007?
Ensure brevity in your answer.  0.75. What is the ratio of the Expenses (in $) of Guatemala in 2001 to that in 2007?
Your response must be concise. 0.59. What is the ratio of the Expenses (in $) in Ireland in 2001 to that in 2007?
Provide a succinct answer. 0.56. What is the ratio of the Expenses (in $) of Macao in 2001 to that in 2007?
Make the answer very short. 0.56. What is the ratio of the Expenses (in $) of Guatemala in 2002 to that in 2003?
Provide a succinct answer. 0.83. What is the ratio of the Expenses (in $) of Ireland in 2002 to that in 2003?
Ensure brevity in your answer.  0.93. What is the ratio of the Expenses (in $) of Macao in 2002 to that in 2003?
Provide a succinct answer. 0.92. What is the ratio of the Expenses (in $) in Grenada in 2002 to that in 2004?
Offer a terse response. 0.88. What is the ratio of the Expenses (in $) of Guatemala in 2002 to that in 2004?
Ensure brevity in your answer.  0.86. What is the ratio of the Expenses (in $) of Ireland in 2002 to that in 2004?
Offer a very short reply. 0.86. What is the ratio of the Expenses (in $) in Macao in 2002 to that in 2004?
Your response must be concise. 0.87. What is the ratio of the Expenses (in $) in Grenada in 2002 to that in 2005?
Your answer should be very brief. 0.94. What is the ratio of the Expenses (in $) of Guatemala in 2002 to that in 2005?
Make the answer very short. 0.78. What is the ratio of the Expenses (in $) of Ireland in 2002 to that in 2005?
Offer a very short reply. 0.77. What is the ratio of the Expenses (in $) of Macao in 2002 to that in 2005?
Keep it short and to the point. 0.79. What is the ratio of the Expenses (in $) in Grenada in 2002 to that in 2006?
Your answer should be very brief. 0.89. What is the ratio of the Expenses (in $) of Guatemala in 2002 to that in 2006?
Offer a very short reply. 0.69. What is the ratio of the Expenses (in $) of Ireland in 2002 to that in 2006?
Provide a short and direct response. 0.7. What is the ratio of the Expenses (in $) in Macao in 2002 to that in 2006?
Ensure brevity in your answer.  0.68. What is the ratio of the Expenses (in $) of Grenada in 2002 to that in 2007?
Your answer should be very brief. 0.82. What is the ratio of the Expenses (in $) of Guatemala in 2002 to that in 2007?
Make the answer very short. 0.64. What is the ratio of the Expenses (in $) of Ireland in 2002 to that in 2007?
Your response must be concise. 0.63. What is the ratio of the Expenses (in $) of Macao in 2002 to that in 2007?
Offer a terse response. 0.59. What is the ratio of the Expenses (in $) in Grenada in 2003 to that in 2004?
Offer a terse response. 0.89. What is the ratio of the Expenses (in $) of Guatemala in 2003 to that in 2004?
Ensure brevity in your answer.  1.03. What is the ratio of the Expenses (in $) of Ireland in 2003 to that in 2004?
Offer a very short reply. 0.93. What is the ratio of the Expenses (in $) of Macao in 2003 to that in 2004?
Give a very brief answer. 0.95. What is the ratio of the Expenses (in $) in Grenada in 2003 to that in 2005?
Ensure brevity in your answer.  0.95. What is the ratio of the Expenses (in $) in Guatemala in 2003 to that in 2005?
Provide a short and direct response. 0.94. What is the ratio of the Expenses (in $) of Ireland in 2003 to that in 2005?
Provide a succinct answer. 0.83. What is the ratio of the Expenses (in $) of Macao in 2003 to that in 2005?
Ensure brevity in your answer.  0.86. What is the ratio of the Expenses (in $) in Grenada in 2003 to that in 2006?
Keep it short and to the point. 0.9. What is the ratio of the Expenses (in $) in Guatemala in 2003 to that in 2006?
Make the answer very short. 0.83. What is the ratio of the Expenses (in $) in Ireland in 2003 to that in 2006?
Keep it short and to the point. 0.76. What is the ratio of the Expenses (in $) of Macao in 2003 to that in 2006?
Your response must be concise. 0.75. What is the ratio of the Expenses (in $) of Grenada in 2003 to that in 2007?
Offer a terse response. 0.83. What is the ratio of the Expenses (in $) in Guatemala in 2003 to that in 2007?
Provide a succinct answer. 0.77. What is the ratio of the Expenses (in $) of Ireland in 2003 to that in 2007?
Your response must be concise. 0.68. What is the ratio of the Expenses (in $) of Macao in 2003 to that in 2007?
Give a very brief answer. 0.65. What is the ratio of the Expenses (in $) in Grenada in 2004 to that in 2005?
Your response must be concise. 1.07. What is the ratio of the Expenses (in $) of Guatemala in 2004 to that in 2005?
Keep it short and to the point. 0.91. What is the ratio of the Expenses (in $) in Ireland in 2004 to that in 2005?
Your answer should be very brief. 0.89. What is the ratio of the Expenses (in $) in Macao in 2004 to that in 2005?
Make the answer very short. 0.9. What is the ratio of the Expenses (in $) in Grenada in 2004 to that in 2006?
Offer a terse response. 1.01. What is the ratio of the Expenses (in $) in Guatemala in 2004 to that in 2006?
Ensure brevity in your answer.  0.81. What is the ratio of the Expenses (in $) of Ireland in 2004 to that in 2006?
Give a very brief answer. 0.81. What is the ratio of the Expenses (in $) of Macao in 2004 to that in 2006?
Give a very brief answer. 0.78. What is the ratio of the Expenses (in $) in Grenada in 2004 to that in 2007?
Keep it short and to the point. 0.93. What is the ratio of the Expenses (in $) of Guatemala in 2004 to that in 2007?
Provide a short and direct response. 0.74. What is the ratio of the Expenses (in $) of Ireland in 2004 to that in 2007?
Ensure brevity in your answer.  0.73. What is the ratio of the Expenses (in $) in Macao in 2004 to that in 2007?
Offer a terse response. 0.68. What is the ratio of the Expenses (in $) of Grenada in 2005 to that in 2006?
Provide a short and direct response. 0.95. What is the ratio of the Expenses (in $) of Guatemala in 2005 to that in 2006?
Make the answer very short. 0.89. What is the ratio of the Expenses (in $) of Ireland in 2005 to that in 2006?
Ensure brevity in your answer.  0.91. What is the ratio of the Expenses (in $) of Macao in 2005 to that in 2006?
Make the answer very short. 0.87. What is the ratio of the Expenses (in $) of Grenada in 2005 to that in 2007?
Keep it short and to the point. 0.87. What is the ratio of the Expenses (in $) in Guatemala in 2005 to that in 2007?
Your answer should be compact. 0.82. What is the ratio of the Expenses (in $) in Ireland in 2005 to that in 2007?
Give a very brief answer. 0.81. What is the ratio of the Expenses (in $) of Macao in 2005 to that in 2007?
Offer a very short reply. 0.75. What is the ratio of the Expenses (in $) in Grenada in 2006 to that in 2007?
Offer a very short reply. 0.92. What is the ratio of the Expenses (in $) of Guatemala in 2006 to that in 2007?
Provide a succinct answer. 0.92. What is the ratio of the Expenses (in $) in Ireland in 2006 to that in 2007?
Give a very brief answer. 0.9. What is the ratio of the Expenses (in $) in Macao in 2006 to that in 2007?
Provide a succinct answer. 0.87. What is the difference between the highest and the second highest Expenses (in $) in Grenada?
Provide a short and direct response. 2.52e+07. What is the difference between the highest and the second highest Expenses (in $) of Guatemala?
Your answer should be very brief. 2.70e+09. What is the difference between the highest and the second highest Expenses (in $) in Ireland?
Your response must be concise. 6.45e+09. What is the difference between the highest and the second highest Expenses (in $) of Macao?
Provide a short and direct response. 2.00e+09. What is the difference between the highest and the lowest Expenses (in $) in Grenada?
Your answer should be very brief. 8.76e+07. What is the difference between the highest and the lowest Expenses (in $) in Guatemala?
Offer a terse response. 1.32e+1. What is the difference between the highest and the lowest Expenses (in $) in Ireland?
Offer a terse response. 2.70e+1. What is the difference between the highest and the lowest Expenses (in $) of Macao?
Make the answer very short. 6.50e+09. 